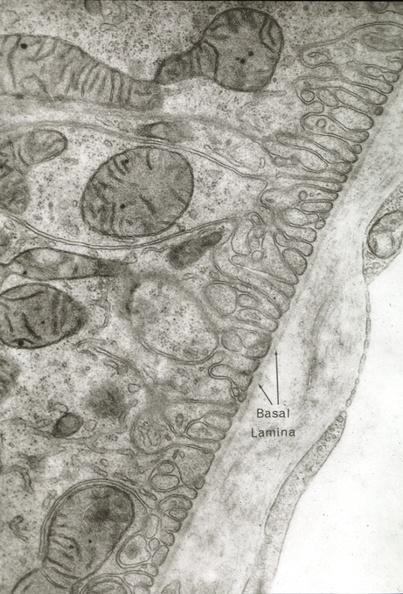where is this mage from?
Answer the question using a single word or phrase. Capillary 